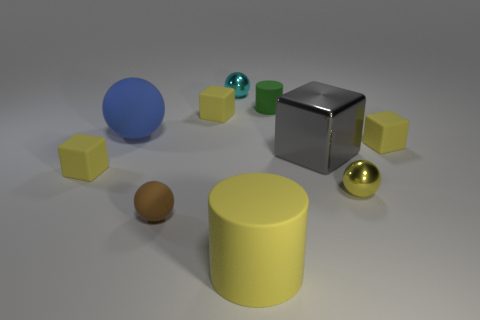Subtract all gray cylinders. How many yellow cubes are left? 3 Subtract all matte blocks. How many blocks are left? 1 Subtract all gray blocks. How many blocks are left? 3 Subtract all green balls. Subtract all green cubes. How many balls are left? 4 Subtract all blocks. How many objects are left? 6 Add 6 small yellow matte things. How many small yellow matte things are left? 9 Add 2 small matte blocks. How many small matte blocks exist? 5 Subtract 0 purple cylinders. How many objects are left? 10 Subtract all big cyan rubber things. Subtract all brown rubber balls. How many objects are left? 9 